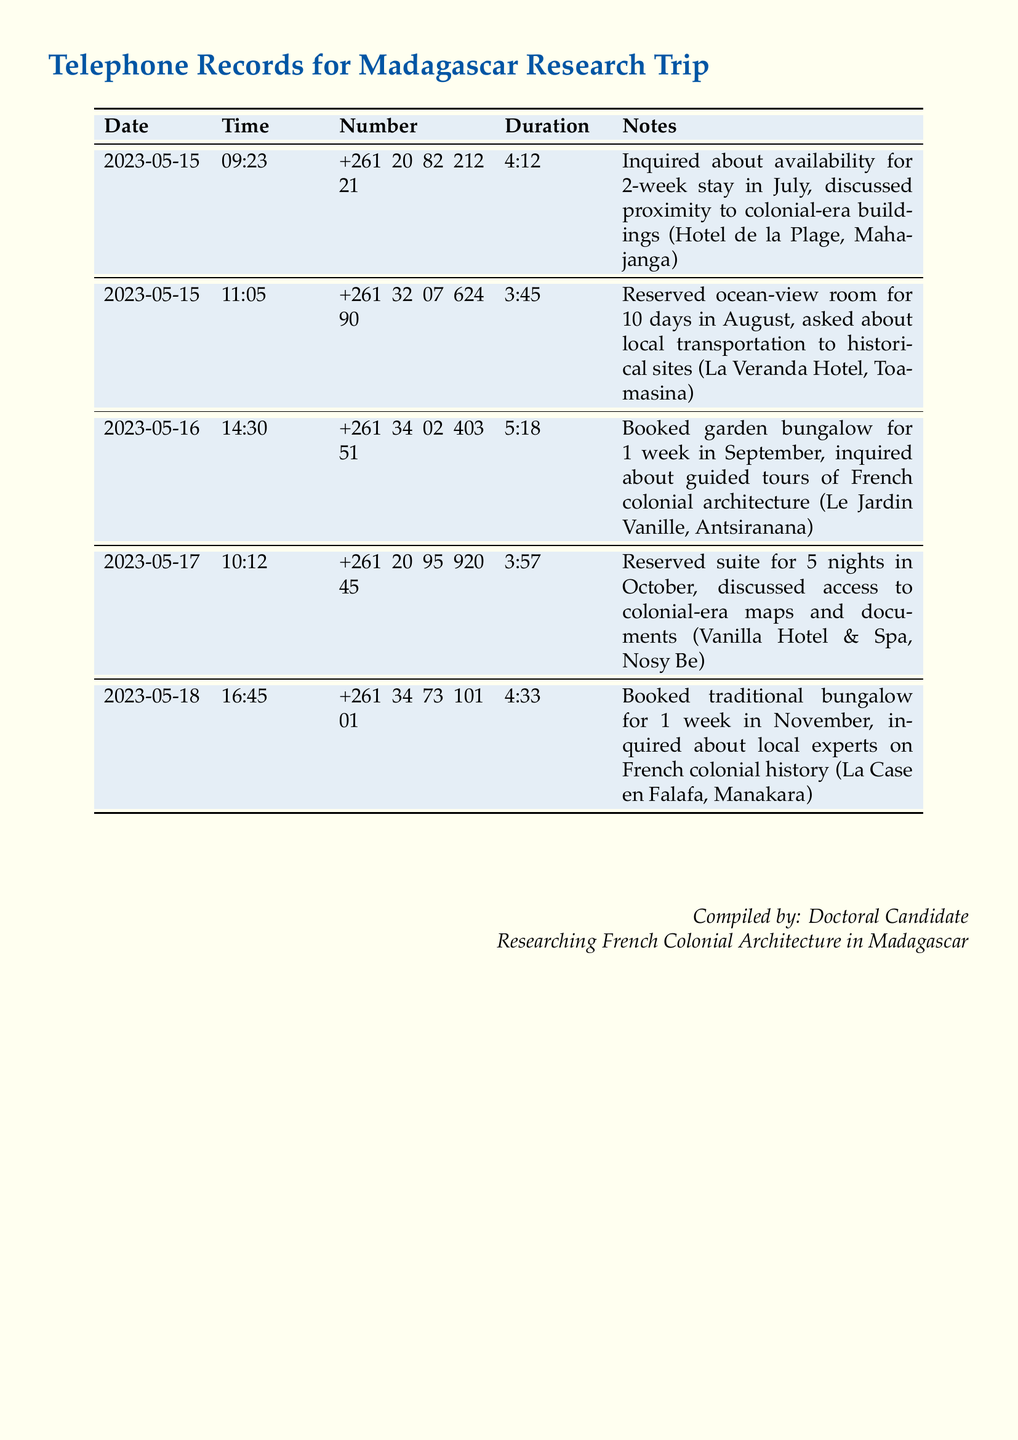what is the first date recorded in the document? The first record in the document lists the date as 2023-05-15.
Answer: 2023-05-15 which hotel has a booking for a 1-week stay in September? The booking for a 1-week stay in September is at Le Jardin Vanille.
Answer: Le Jardin Vanille how long is the duration of the call made to La Veranda Hotel? The duration of the call made to La Veranda Hotel is 3 minutes and 45 seconds.
Answer: 3:45 what type of accommodation was reserved at La Case en Falafa? The accommodation reserved at La Case en Falafa is a traditional bungalow.
Answer: traditional bungalow how many nights was the suite reserved at Vanilla Hotel & Spa? The suite at Vanilla Hotel & Spa was reserved for 5 nights.
Answer: 5 nights which coastal city is associated with Hotel de la Plage? Hotel de la Plage is associated with the city of Mahajanga.
Answer: Mahajanga what question was asked during the call to Vanilla Hotel & Spa? During the call, access to colonial-era maps and documents was discussed.
Answer: access to colonial-era maps and documents how many calls are documented in total? There are 5 calls documented in total.
Answer: 5 what time was the call made to inquire about guided tours of French colonial architecture? The call to inquire about guided tours was made at 14:30.
Answer: 14:30 